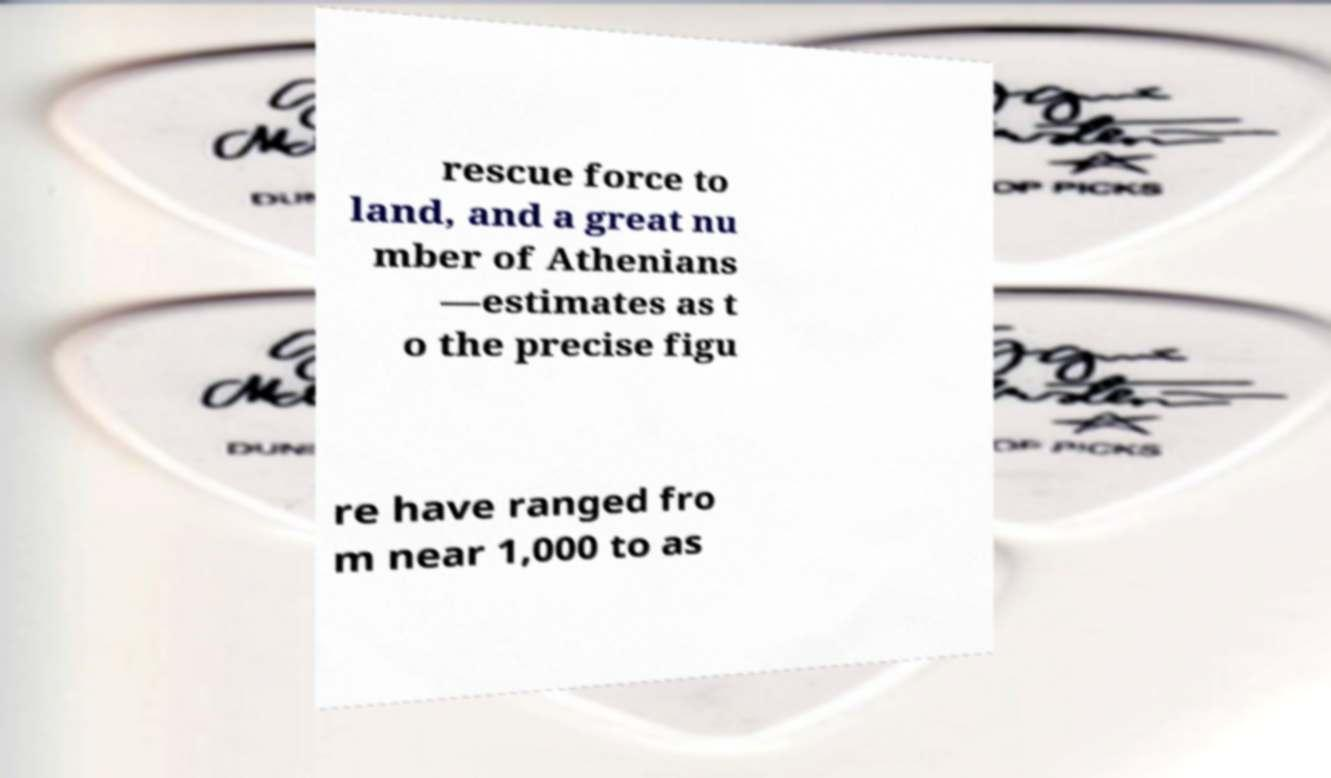Could you assist in decoding the text presented in this image and type it out clearly? rescue force to land, and a great nu mber of Athenians —estimates as t o the precise figu re have ranged fro m near 1,000 to as 